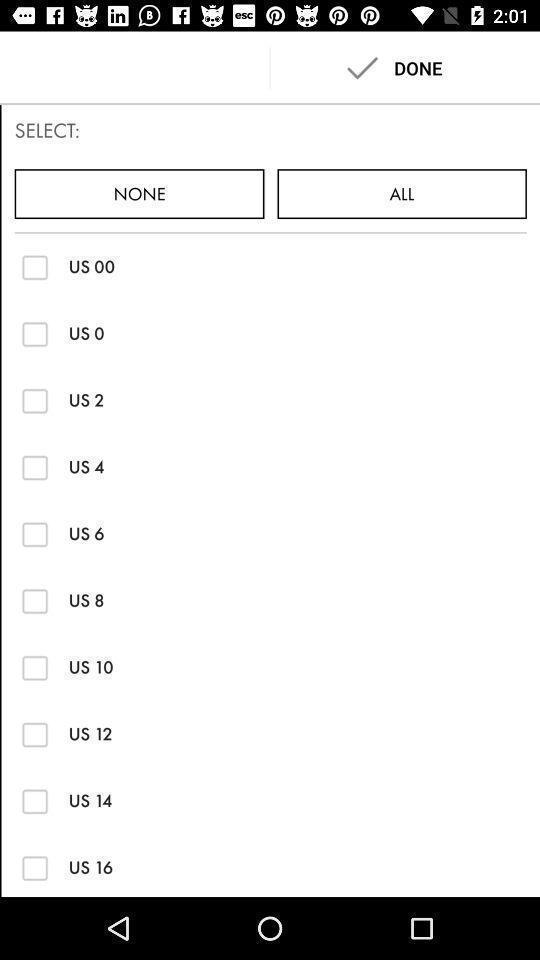What details can you identify in this image? Screen shows to select size. 